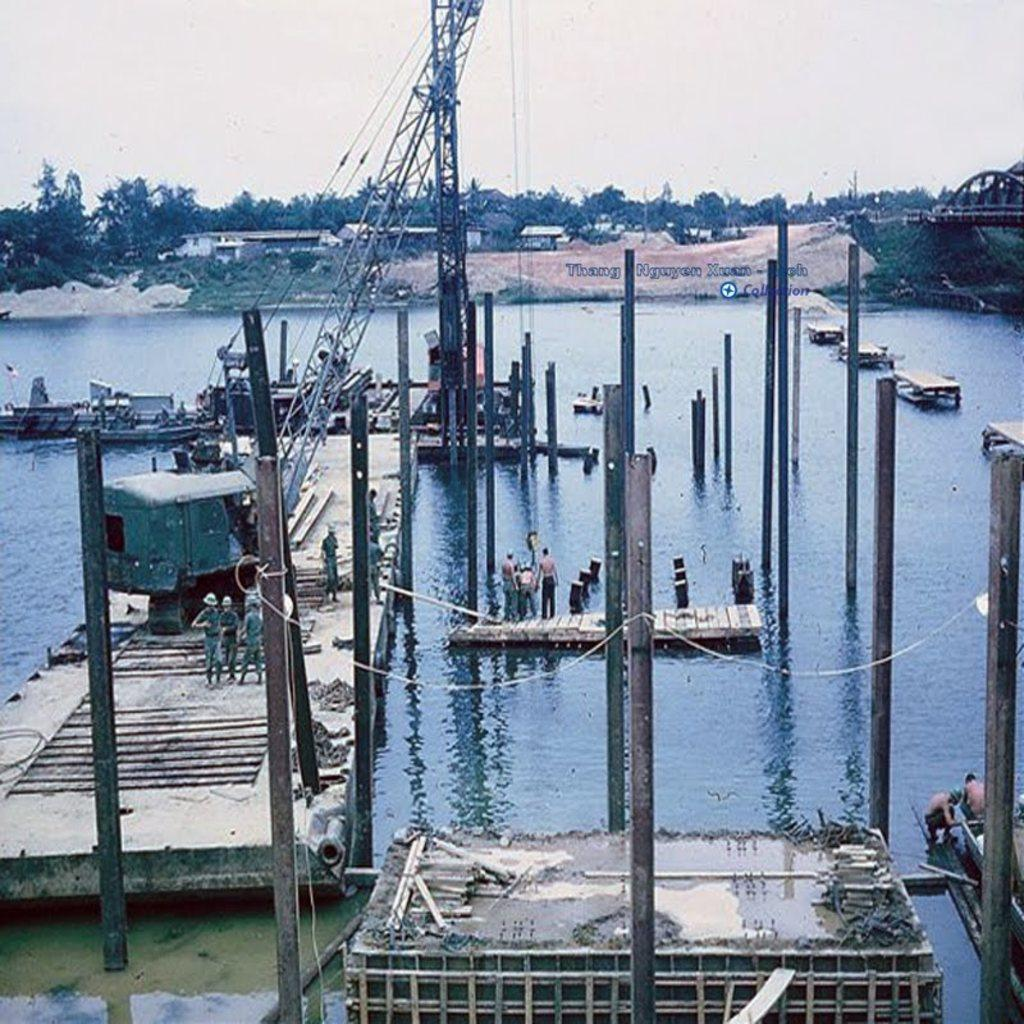Where is the image taken? The image is taken near a river. What can be seen on the bench in the image? There is construction equipment on a bench in the image. What is being built in the river? Pillars are being built in the river. What is the purpose of the branch in the image? There is no branch present in the image. 